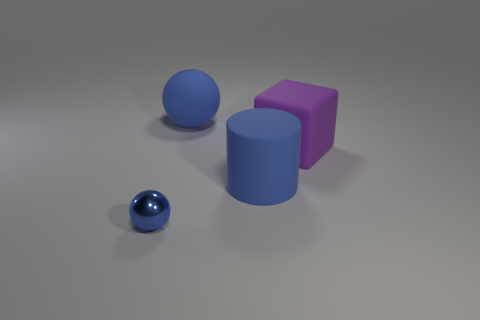Add 1 big purple blocks. How many objects exist? 5 Subtract all cylinders. How many objects are left? 3 Subtract 1 blue spheres. How many objects are left? 3 Subtract all tiny matte balls. Subtract all blue objects. How many objects are left? 1 Add 1 big blue rubber cylinders. How many big blue rubber cylinders are left? 2 Add 4 small red shiny things. How many small red shiny things exist? 4 